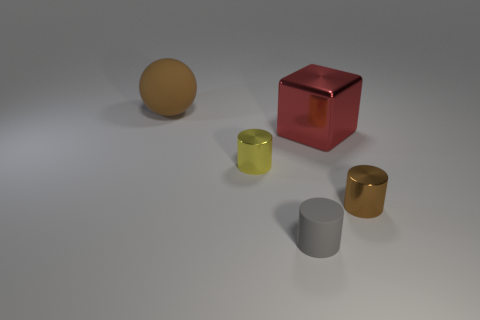Is there anything else that has the same shape as the big red thing?
Provide a succinct answer. No. What number of things are behind the yellow cylinder and in front of the ball?
Make the answer very short. 1. What is the shape of the thing that is to the left of the yellow shiny cylinder?
Offer a very short reply. Sphere. How many other objects have the same size as the gray object?
Your response must be concise. 2. There is a small metal object to the right of the small gray thing; is it the same color as the large metallic cube?
Provide a short and direct response. No. There is a tiny cylinder that is both on the right side of the tiny yellow shiny cylinder and on the left side of the shiny block; what is its material?
Make the answer very short. Rubber. Is the number of metallic blocks greater than the number of tiny brown shiny balls?
Offer a very short reply. Yes. What is the color of the rubber object that is in front of the brown object that is right of the large thing in front of the brown matte sphere?
Give a very brief answer. Gray. Is the material of the tiny cylinder that is behind the small brown cylinder the same as the tiny brown cylinder?
Give a very brief answer. Yes. Is there a small cylinder that has the same color as the large sphere?
Your answer should be very brief. Yes. 